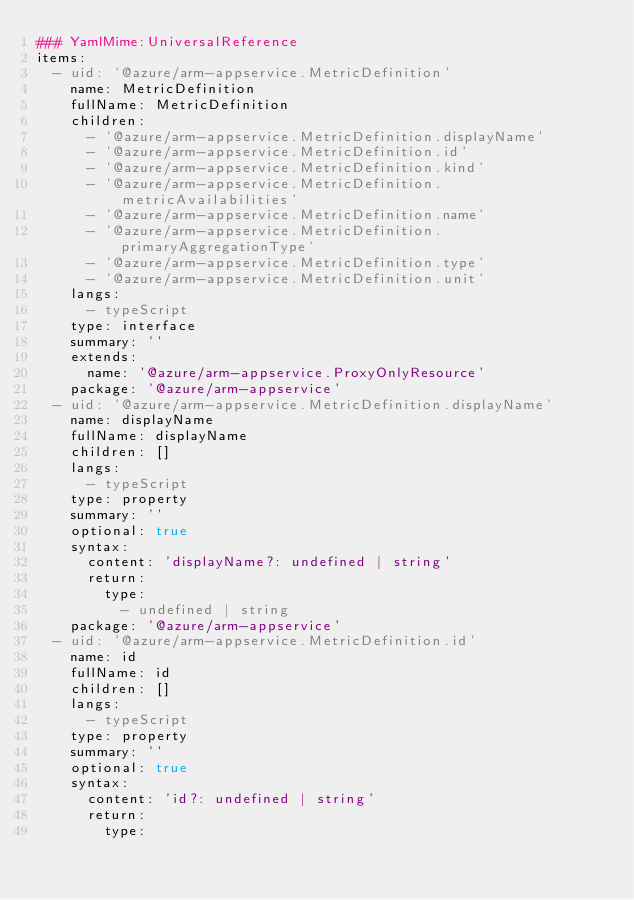<code> <loc_0><loc_0><loc_500><loc_500><_YAML_>### YamlMime:UniversalReference
items:
  - uid: '@azure/arm-appservice.MetricDefinition'
    name: MetricDefinition
    fullName: MetricDefinition
    children:
      - '@azure/arm-appservice.MetricDefinition.displayName'
      - '@azure/arm-appservice.MetricDefinition.id'
      - '@azure/arm-appservice.MetricDefinition.kind'
      - '@azure/arm-appservice.MetricDefinition.metricAvailabilities'
      - '@azure/arm-appservice.MetricDefinition.name'
      - '@azure/arm-appservice.MetricDefinition.primaryAggregationType'
      - '@azure/arm-appservice.MetricDefinition.type'
      - '@azure/arm-appservice.MetricDefinition.unit'
    langs:
      - typeScript
    type: interface
    summary: ''
    extends:
      name: '@azure/arm-appservice.ProxyOnlyResource'
    package: '@azure/arm-appservice'
  - uid: '@azure/arm-appservice.MetricDefinition.displayName'
    name: displayName
    fullName: displayName
    children: []
    langs:
      - typeScript
    type: property
    summary: ''
    optional: true
    syntax:
      content: 'displayName?: undefined | string'
      return:
        type:
          - undefined | string
    package: '@azure/arm-appservice'
  - uid: '@azure/arm-appservice.MetricDefinition.id'
    name: id
    fullName: id
    children: []
    langs:
      - typeScript
    type: property
    summary: ''
    optional: true
    syntax:
      content: 'id?: undefined | string'
      return:
        type:</code> 